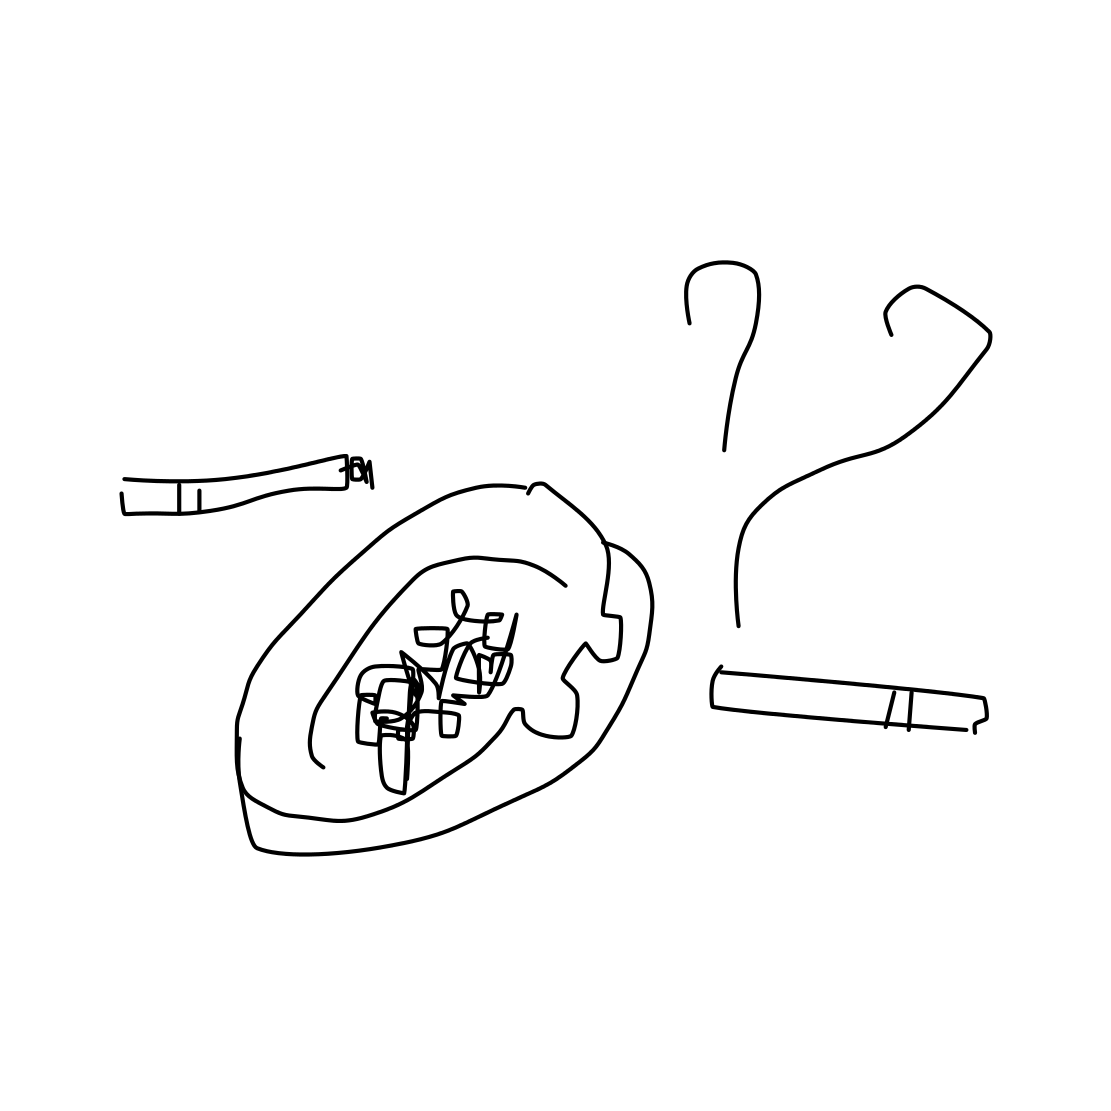Is the style of the drawing indicative of any particular artistic movement or style? The drawing's simplistic and sketch-like quality might be reflective of minimalism or could suggest a more personal, intimate form of expression rather than following a formal artistic movement. Could this image be telling us something about the artist's views on smoking? Potentially yes. The straightforward depiction of the ashtray and cigarettes, without any embellishments, might imply the artist's straightforward stance on smoking, possibly hinting at the negative aspects of the habit as it is presented without glamour. 